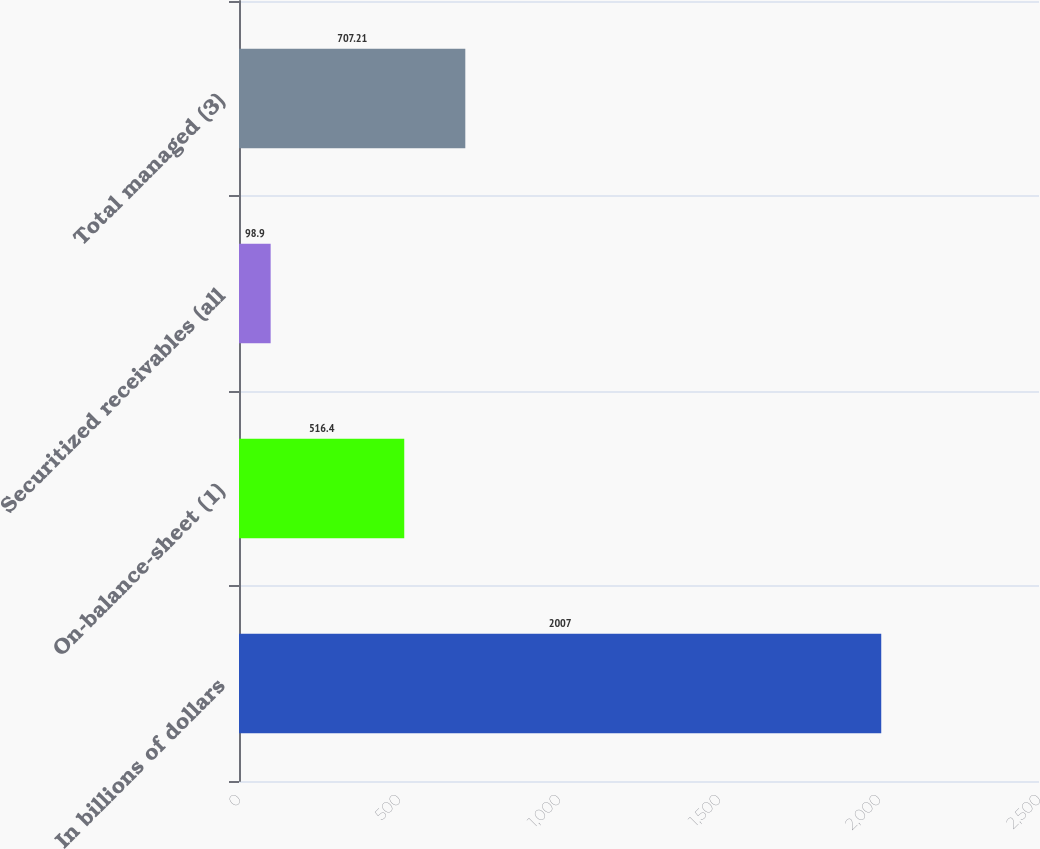Convert chart to OTSL. <chart><loc_0><loc_0><loc_500><loc_500><bar_chart><fcel>In billions of dollars<fcel>On-balance-sheet (1)<fcel>Securitized receivables (all<fcel>Total managed (3)<nl><fcel>2007<fcel>516.4<fcel>98.9<fcel>707.21<nl></chart> 